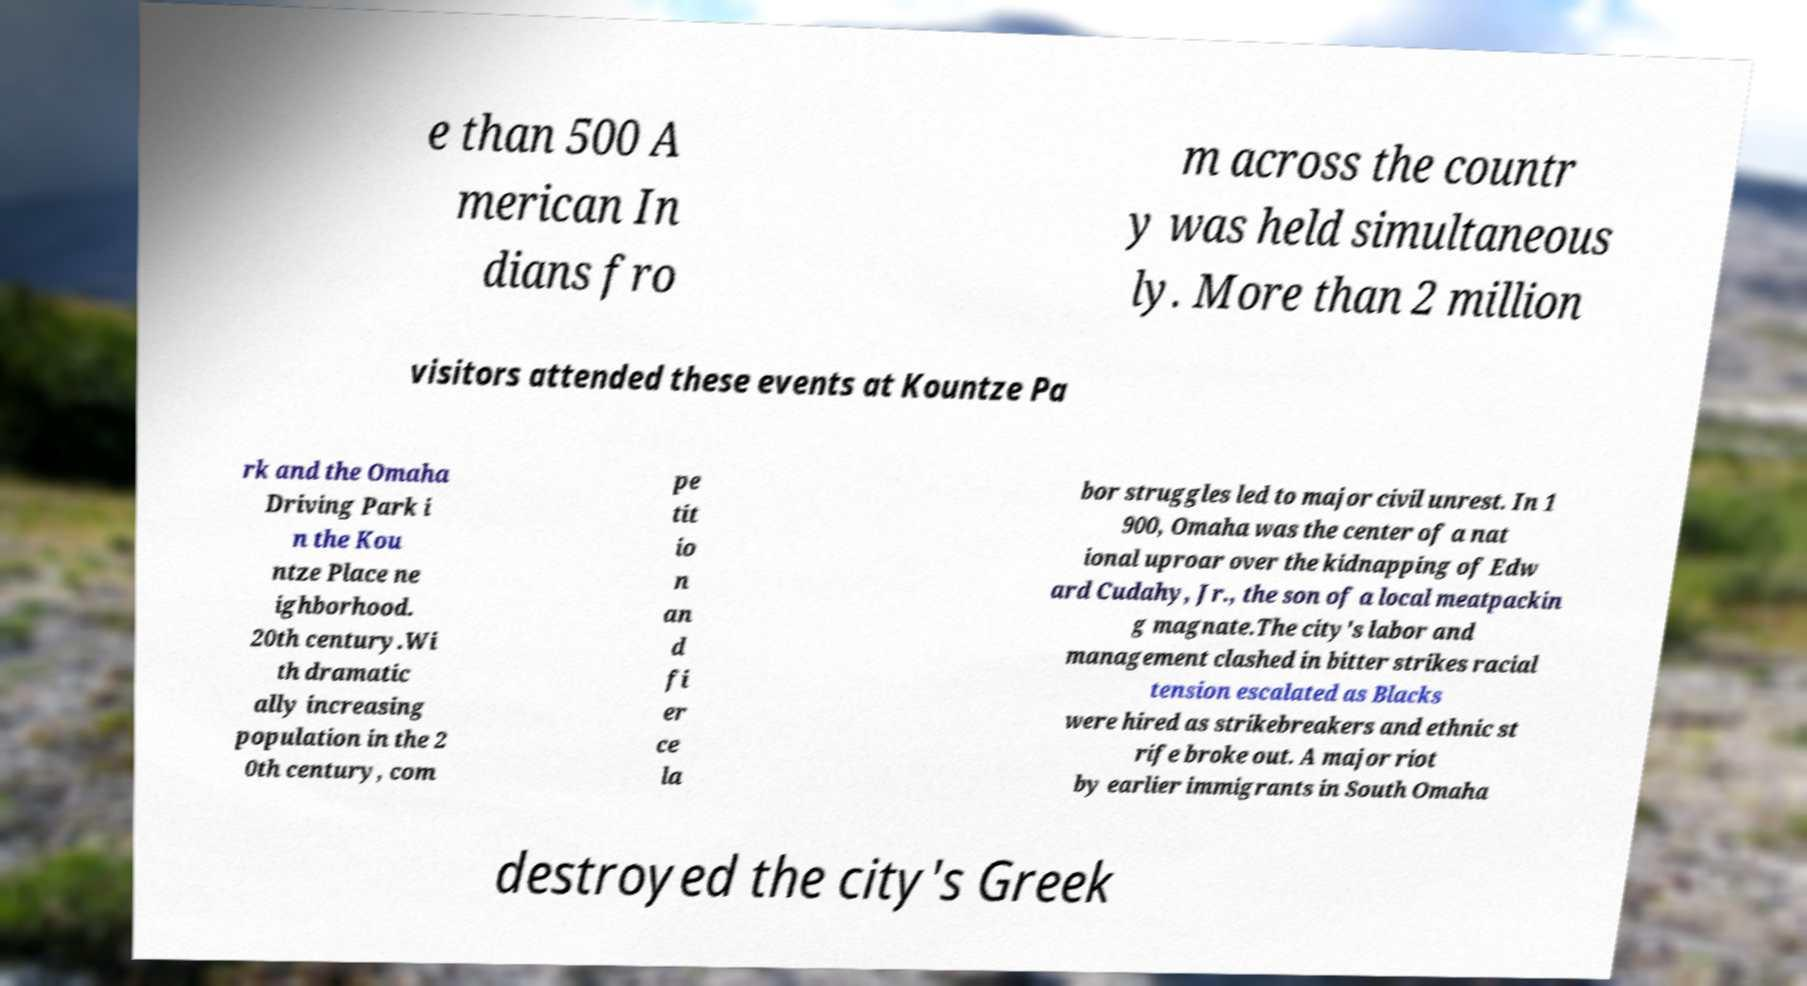For documentation purposes, I need the text within this image transcribed. Could you provide that? e than 500 A merican In dians fro m across the countr y was held simultaneous ly. More than 2 million visitors attended these events at Kountze Pa rk and the Omaha Driving Park i n the Kou ntze Place ne ighborhood. 20th century.Wi th dramatic ally increasing population in the 2 0th century, com pe tit io n an d fi er ce la bor struggles led to major civil unrest. In 1 900, Omaha was the center of a nat ional uproar over the kidnapping of Edw ard Cudahy, Jr., the son of a local meatpackin g magnate.The city's labor and management clashed in bitter strikes racial tension escalated as Blacks were hired as strikebreakers and ethnic st rife broke out. A major riot by earlier immigrants in South Omaha destroyed the city's Greek 